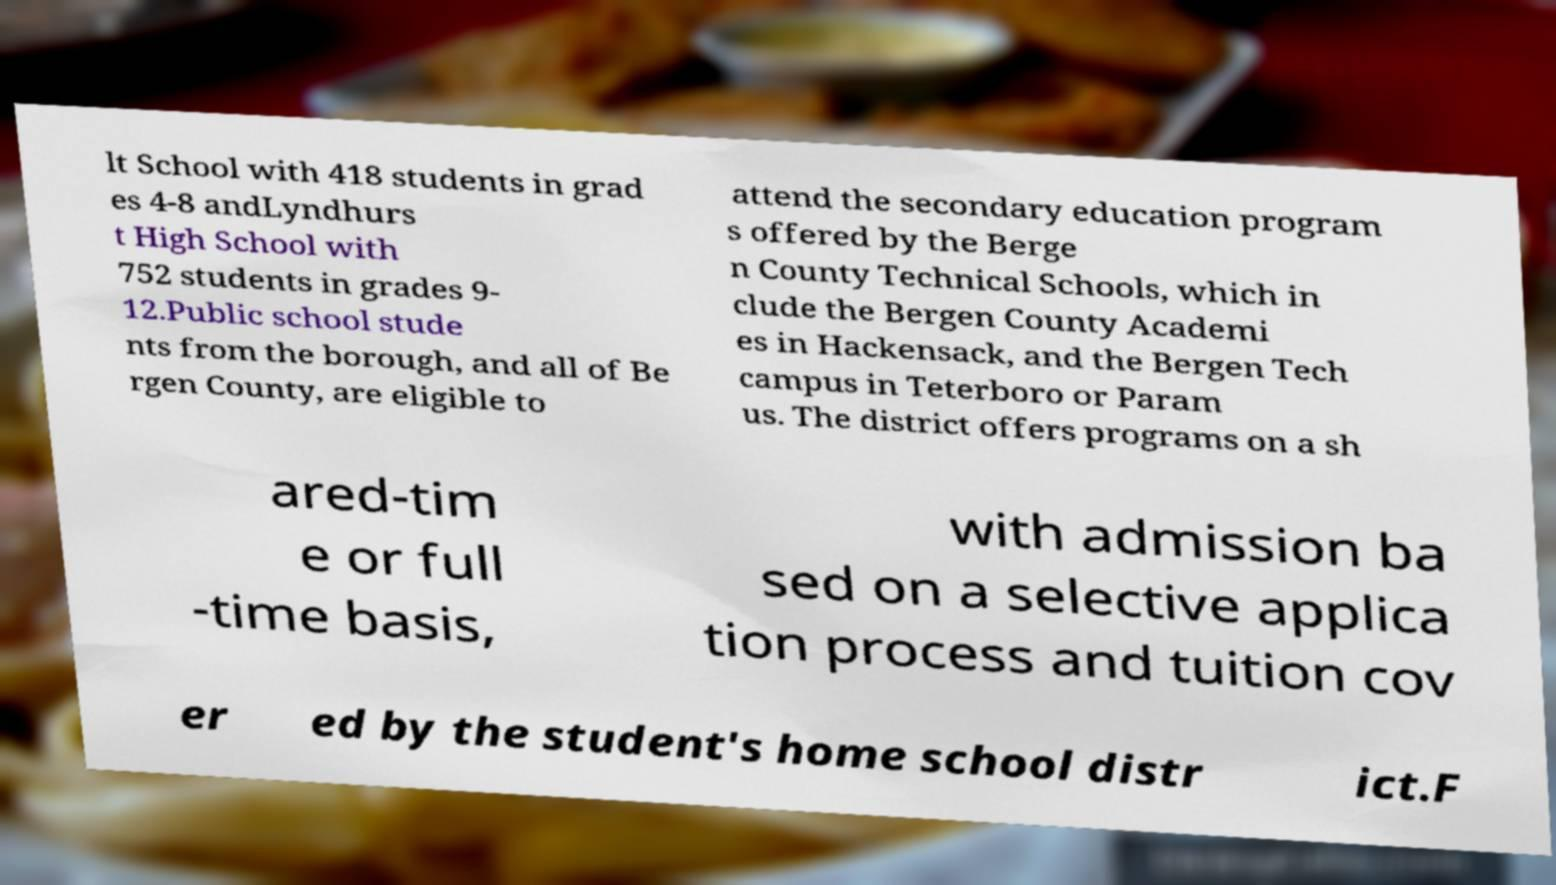Please identify and transcribe the text found in this image. lt School with 418 students in grad es 4-8 andLyndhurs t High School with 752 students in grades 9- 12.Public school stude nts from the borough, and all of Be rgen County, are eligible to attend the secondary education program s offered by the Berge n County Technical Schools, which in clude the Bergen County Academi es in Hackensack, and the Bergen Tech campus in Teterboro or Param us. The district offers programs on a sh ared-tim e or full -time basis, with admission ba sed on a selective applica tion process and tuition cov er ed by the student's home school distr ict.F 